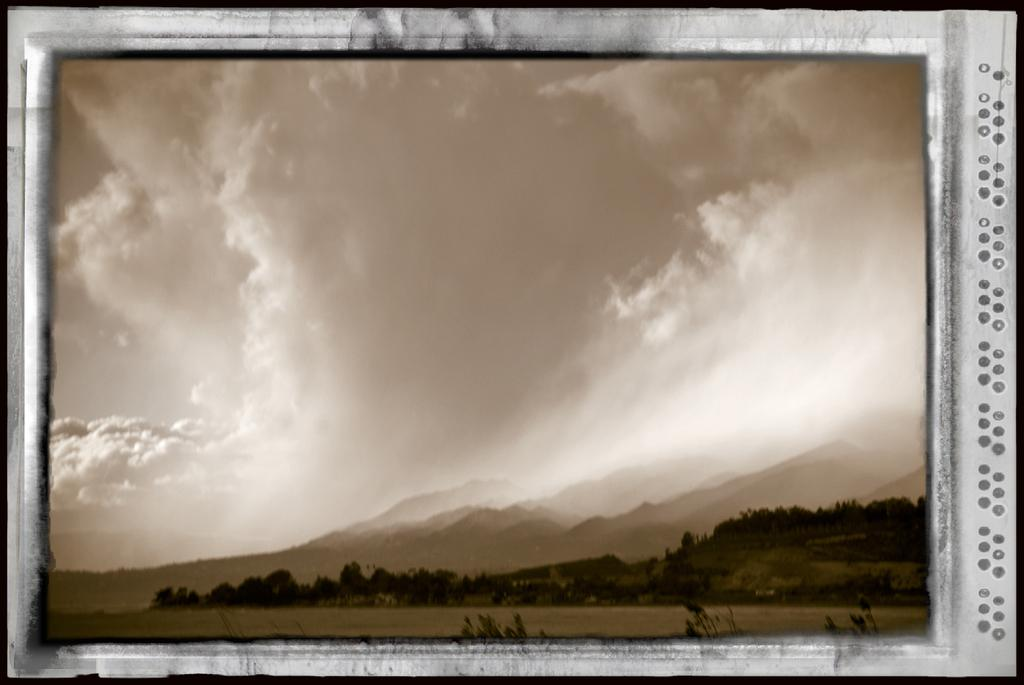What object is present in the image that typically holds a picture? There is a photo frame in the image. What is depicted inside the photo frame? The photo frame contains a ground. What type of natural landscape can be seen in the image? There are mountains in the image. What type of vegetation is present in the image? There are plants in the image. What can be seen in the sky in the image? There are clouds in the sky in the image. What type of salt is sprinkled on the ground in the photo frame? There is no salt present in the image; the photo frame contains a ground with no visible salt. 